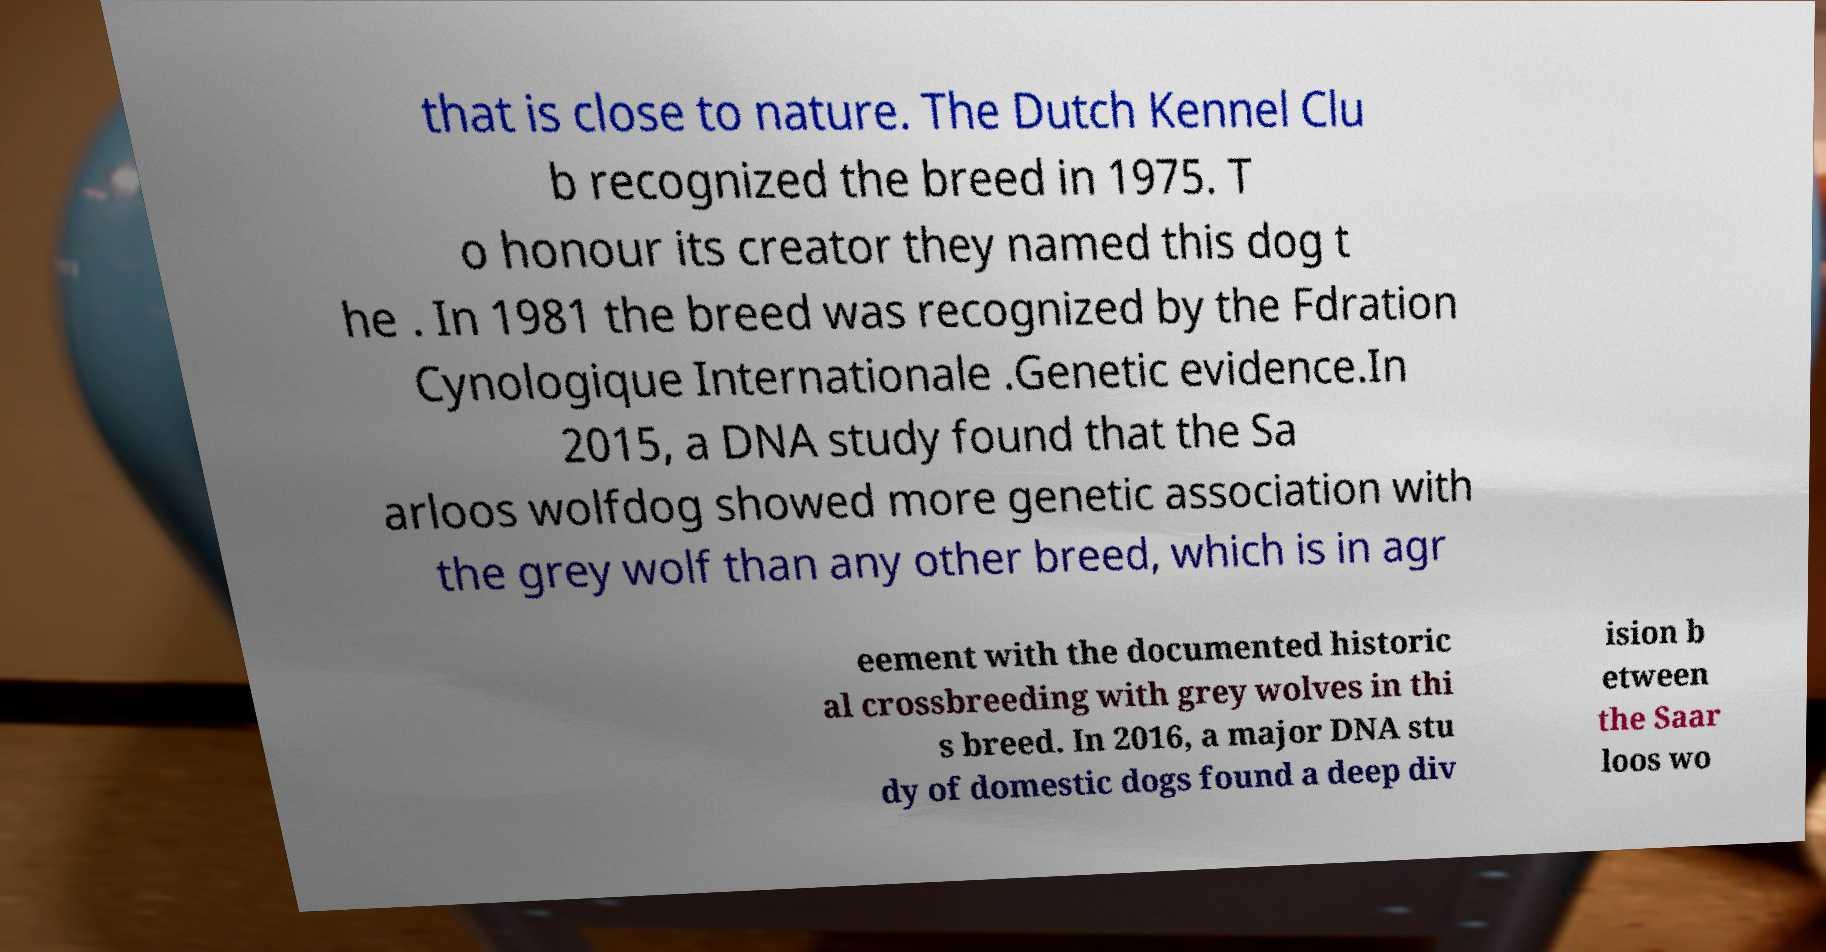There's text embedded in this image that I need extracted. Can you transcribe it verbatim? that is close to nature. The Dutch Kennel Clu b recognized the breed in 1975. T o honour its creator they named this dog t he . In 1981 the breed was recognized by the Fdration Cynologique Internationale .Genetic evidence.In 2015, a DNA study found that the Sa arloos wolfdog showed more genetic association with the grey wolf than any other breed, which is in agr eement with the documented historic al crossbreeding with grey wolves in thi s breed. In 2016, a major DNA stu dy of domestic dogs found a deep div ision b etween the Saar loos wo 